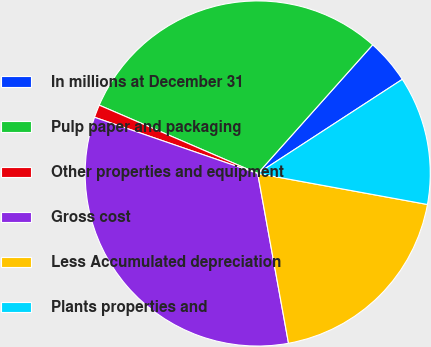Convert chart. <chart><loc_0><loc_0><loc_500><loc_500><pie_chart><fcel>In millions at December 31<fcel>Pulp paper and packaging<fcel>Other properties and equipment<fcel>Gross cost<fcel>Less Accumulated depreciation<fcel>Plants properties and<nl><fcel>4.21%<fcel>30.13%<fcel>1.2%<fcel>33.14%<fcel>19.27%<fcel>12.06%<nl></chart> 